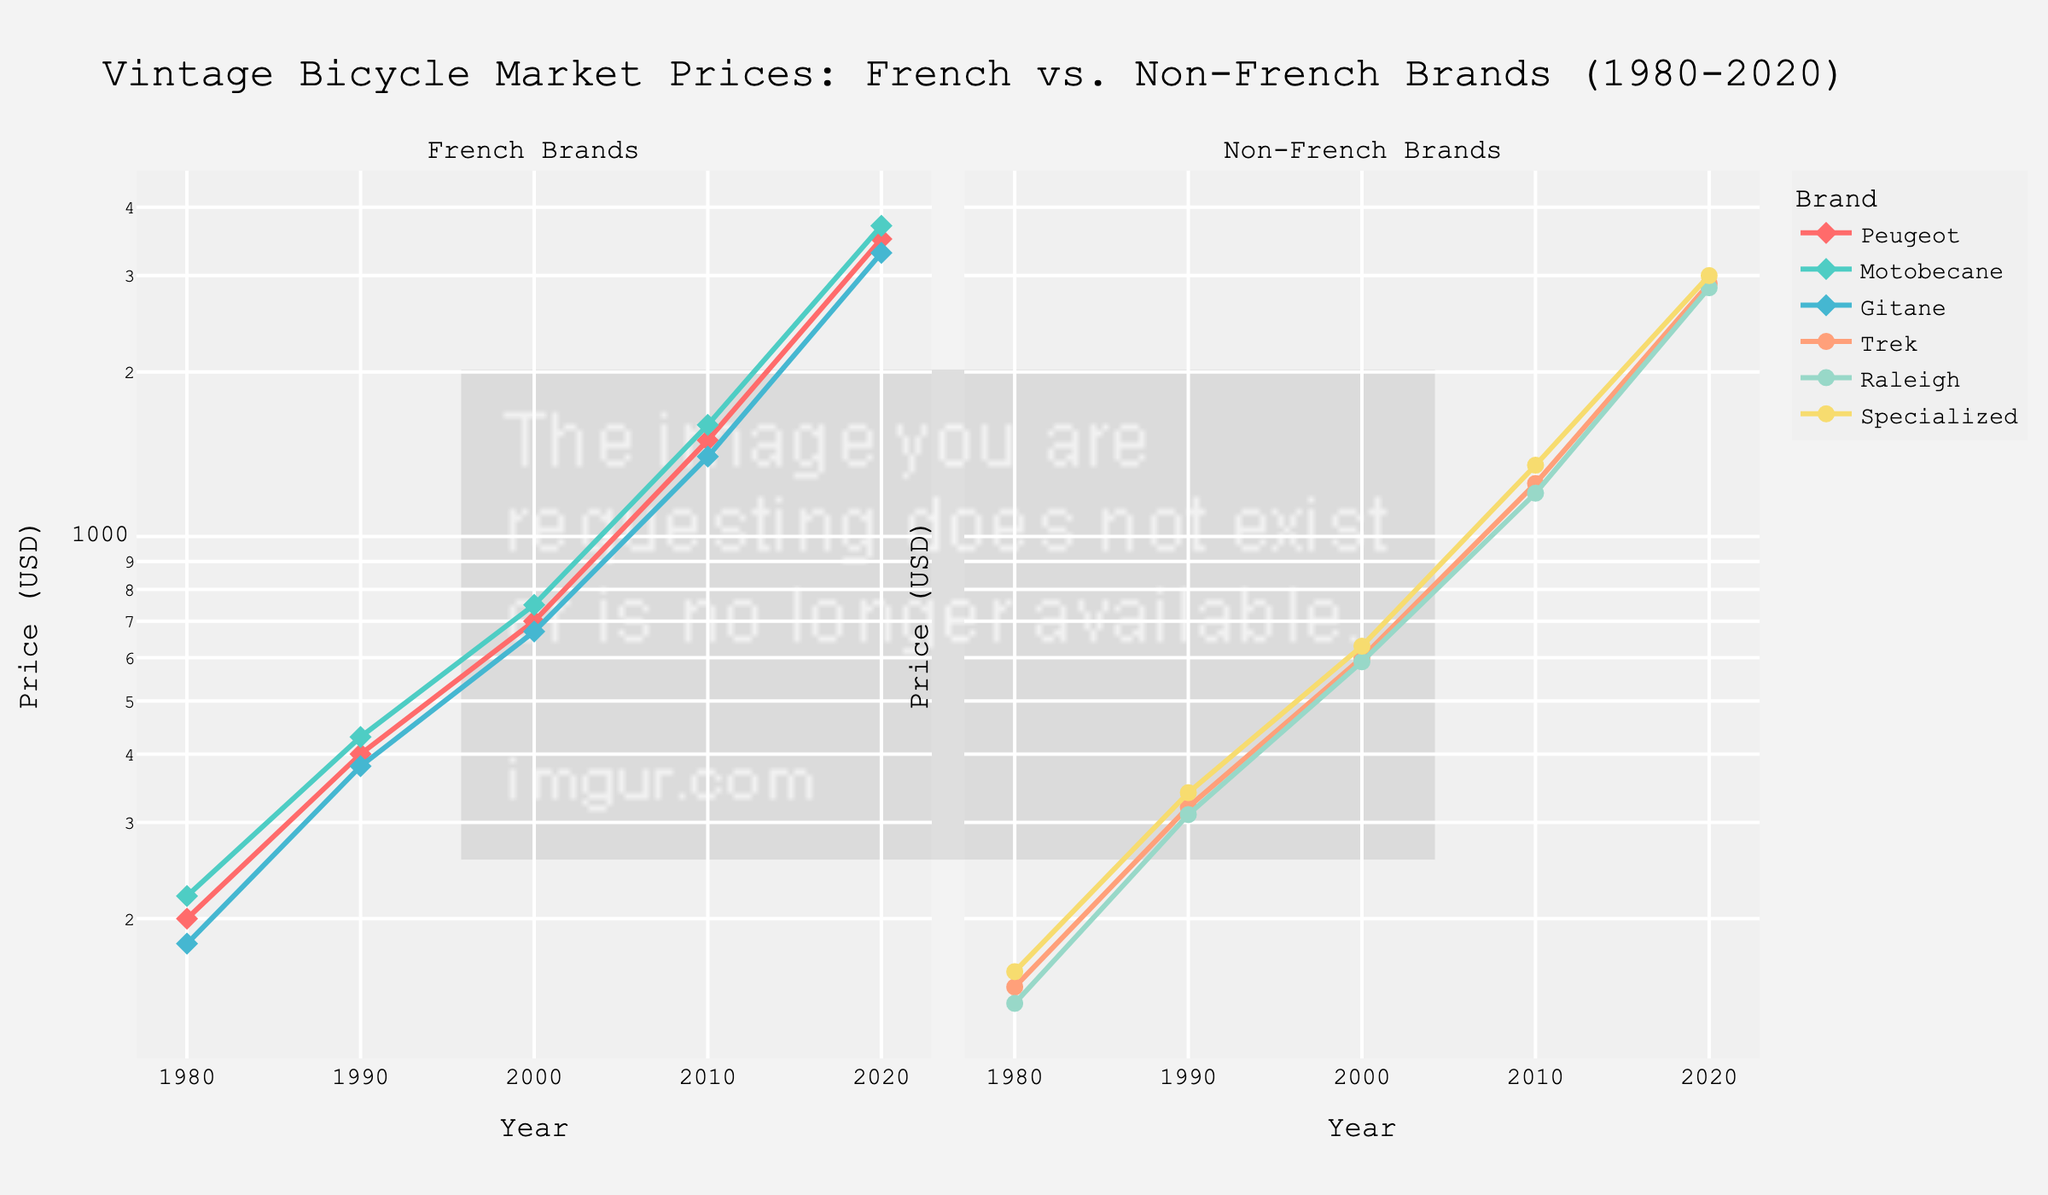Which two French brands had the highest prices in 2020? The subplot on the left shows the prices of various French brands. By comparing the endpoints for 2020, Peugeot and Motobecane show the highest prices.
Answer: Peugeot and Motobecane What is the general trend of vintage bicycle prices from 1980 to 2020? Both subplots show an increasing trend in prices over the years from 1980 to 2020. This indicates rising market prices for vintage bicycles regardless of the brand's country of origin.
Answer: Increasing Which non-French brand had the lowest price in 1980? The subplot on the right lists the years and prices for non-French brands. By comparing the 1980 data points, Raleigh had the lowest price.
Answer: Raleigh By how much did the price of Peugeot bicycles increase from 1980 to 2020? The subplot on the left shows Peugeot prices in 1980 at $200 and in 2020 at $3500. The difference can be calculated as $3500 - $200.
Answer: $3300 How does the price increase of Specialized bicycles compare to Trek from 1980 to 2020? To compare, check the prices of Specialized and Trek in 1980 and 2020 on the right subplot. Specialized increased from $160 to $3000, and Trek from $150 to $2900. Calculate the increase for each: Specialized ($3000-$160) = $2840; Trek ($2900-$150) = $2750.
Answer: Specialized increases more than Trek by $90 ($2840 - $2750) What price did Gitane bicycles peak at based on the visual data? By observing the left subplot, the highest price data point for Gitane is in the year 2020, which is $3300.
Answer: $3300 Which brand among non-French brands shows the steepest growth between any two consecutive decades? Examine the right subplot for non-French brands. Trek exhibits the steepest growth from 2000 to 2010, increasing from $600 to $1250, which is more than doubling.
Answer: Trek Do the French brands show a consistently higher market price compared to non-French brands in the figure? By comparing the overall trends and positioning of brands in both subplots, it's clear that French brands generally show higher market prices by 2020.
Answer: Yes 